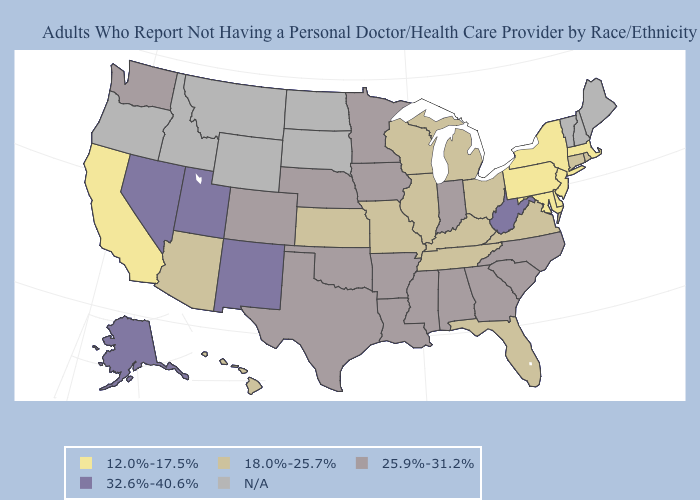What is the lowest value in the South?
Short answer required. 12.0%-17.5%. Does the first symbol in the legend represent the smallest category?
Give a very brief answer. Yes. Which states hav the highest value in the South?
Quick response, please. West Virginia. Name the states that have a value in the range 18.0%-25.7%?
Short answer required. Arizona, Connecticut, Florida, Hawaii, Illinois, Kansas, Kentucky, Michigan, Missouri, Ohio, Rhode Island, Tennessee, Virginia, Wisconsin. How many symbols are there in the legend?
Concise answer only. 5. Does New Mexico have the lowest value in the West?
Short answer required. No. Is the legend a continuous bar?
Short answer required. No. Among the states that border Kentucky , which have the highest value?
Write a very short answer. West Virginia. Name the states that have a value in the range 25.9%-31.2%?
Answer briefly. Alabama, Arkansas, Colorado, Georgia, Indiana, Iowa, Louisiana, Minnesota, Mississippi, Nebraska, North Carolina, Oklahoma, South Carolina, Texas, Washington. Name the states that have a value in the range N/A?
Answer briefly. Idaho, Maine, Montana, New Hampshire, North Dakota, Oregon, South Dakota, Vermont, Wyoming. What is the value of Michigan?
Answer briefly. 18.0%-25.7%. Name the states that have a value in the range 12.0%-17.5%?
Quick response, please. California, Delaware, Maryland, Massachusetts, New Jersey, New York, Pennsylvania. 